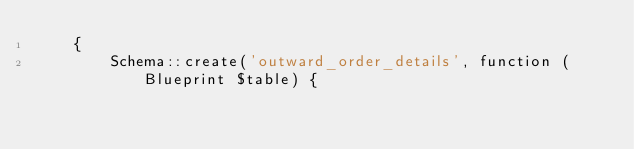Convert code to text. <code><loc_0><loc_0><loc_500><loc_500><_PHP_>    {
        Schema::create('outward_order_details', function (Blueprint $table) {</code> 